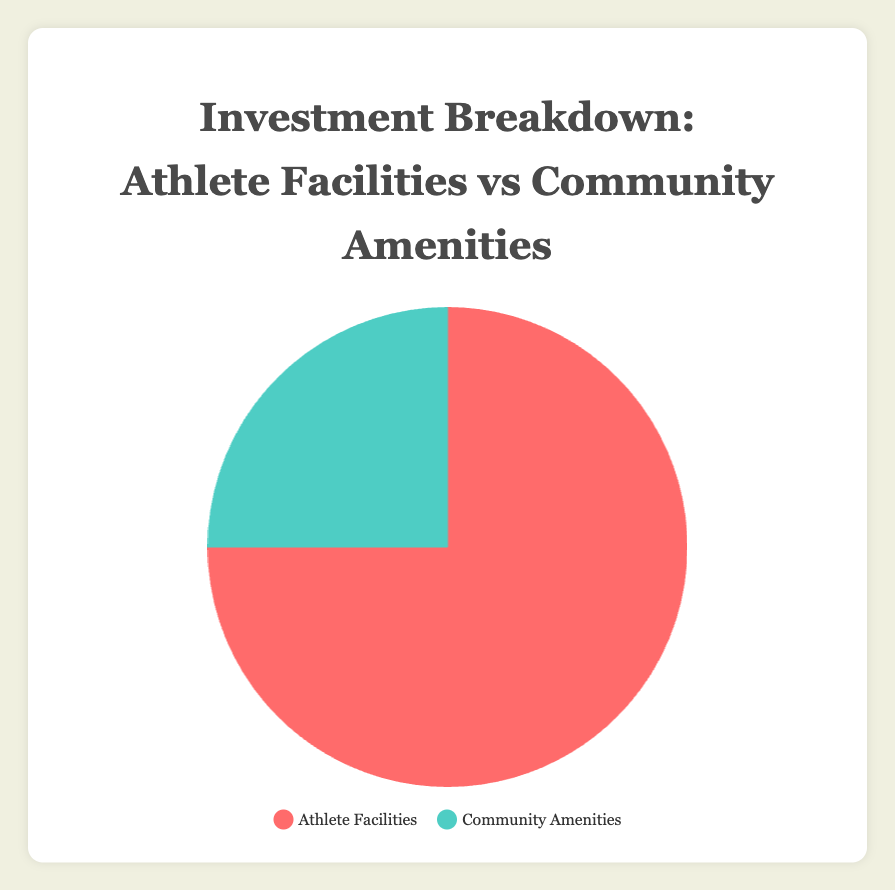How much more investment is made in Athlete Facilities compared to Community Amenities? The slice representing Athlete Facilities is 75%, and the slice for Community Amenities is 25%. Subtracting 25% from 75% gives the difference.
Answer: 50% What percentage of the investment is dedicated to non-athlete-related community amenities? According to the pie chart data, Community Amenities take up 25% of the investment. This is the percentage dedicated to non-athlete-related activities.
Answer: 25% Which category accounts for a greater portion of the investment? The pie chart shows two categories: Athlete Facilities and Community Amenities. Athlete Facilities take up the larger portion at 75%.
Answer: Athlete Facilities If the total investment amount were $1,000,000, how much would be allocated to Community Amenities? By calculating 25% of $1,000,000, you get the allocation for Community Amenities. 0.25 * 1,000,000 = $250,000.
Answer: $250,000 What is the sum of the investments in Community Amenities and the portion of Coaching Staff within the Athlete Facilities? Community Amenities are 25%. Coaching Staff is 15% of Athlete Facilities which is 75%, so 15% * 75% = 11.25%. Adding them together: 25% + 11.25% = 36.25%.
Answer: 36.25% If the pie chart data were to represent a total investment of $500,000, how much would be spent on Athlete Facilities? By calculating 75% of $500,000, you get the allocation for Athlete Facilities. 0.75 * 500,000 = $375,000.
Answer: $375,000 What are the colors representing Athlete Facilities and Community Amenities respectively? The color legend shows that Athlete Facilities are represented by red, and Community Amenities are represented by green.
Answer: Red and Green 